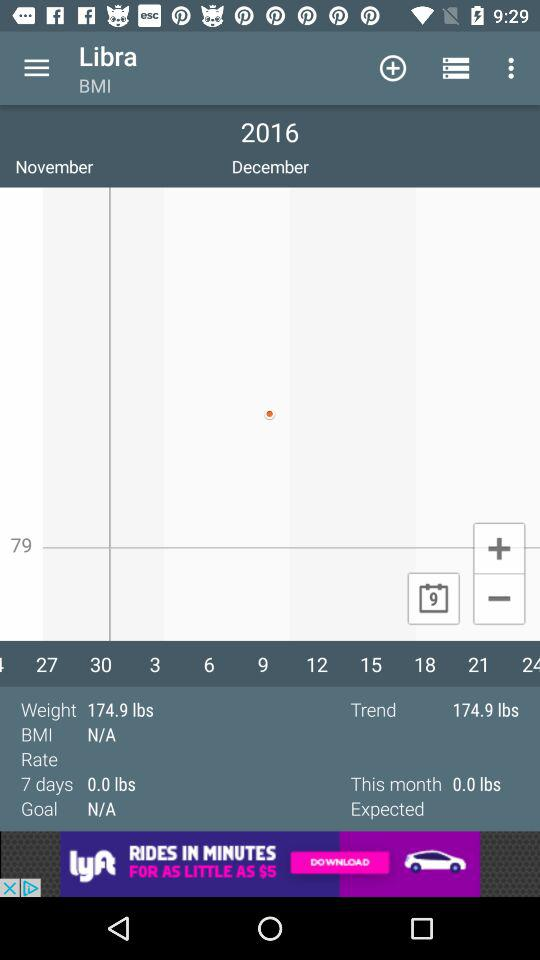What is the BMI? The BMI is N/A. 